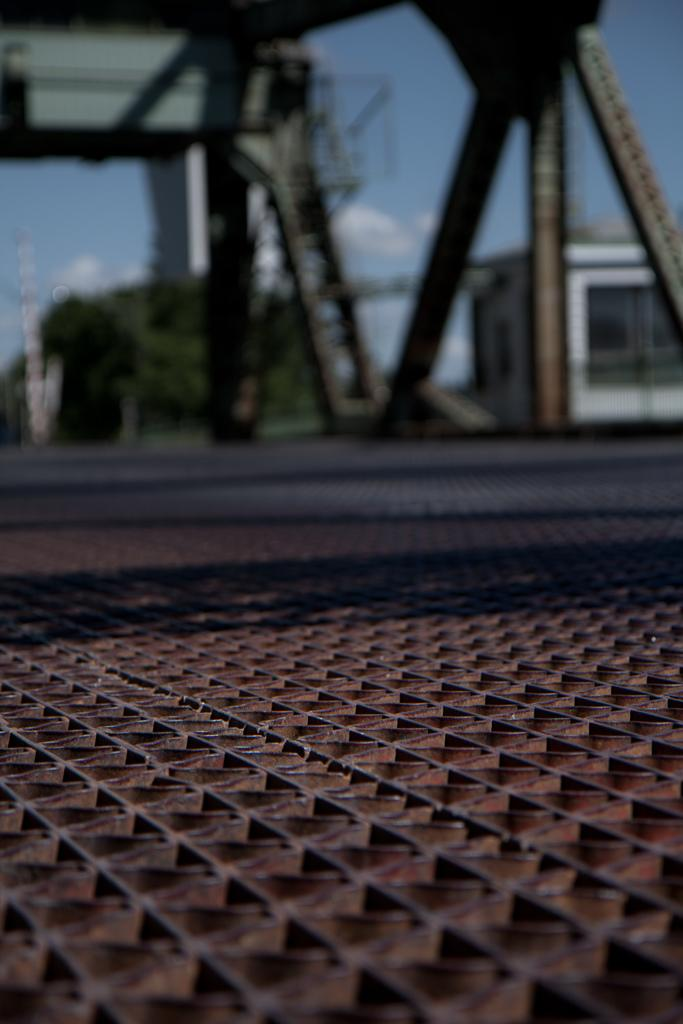What can be seen at the bottom of the image? The ground is visible in the image. How would you describe the appearance of the background in the image? The background in the image is blurred. What type of objects can be seen in the background? Metallic objects, trees, buildings, and the sky are visible in the background. What type of toys are scattered on the ground in the image? There are no toys present in the image; the ground is visible but does not have any toys on it. 